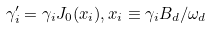Convert formula to latex. <formula><loc_0><loc_0><loc_500><loc_500>\gamma _ { i } ^ { \prime } & = \gamma _ { i } J _ { 0 } ( x _ { i } ) , x _ { i } \equiv \gamma _ { i } B _ { d } / \omega _ { d }</formula> 